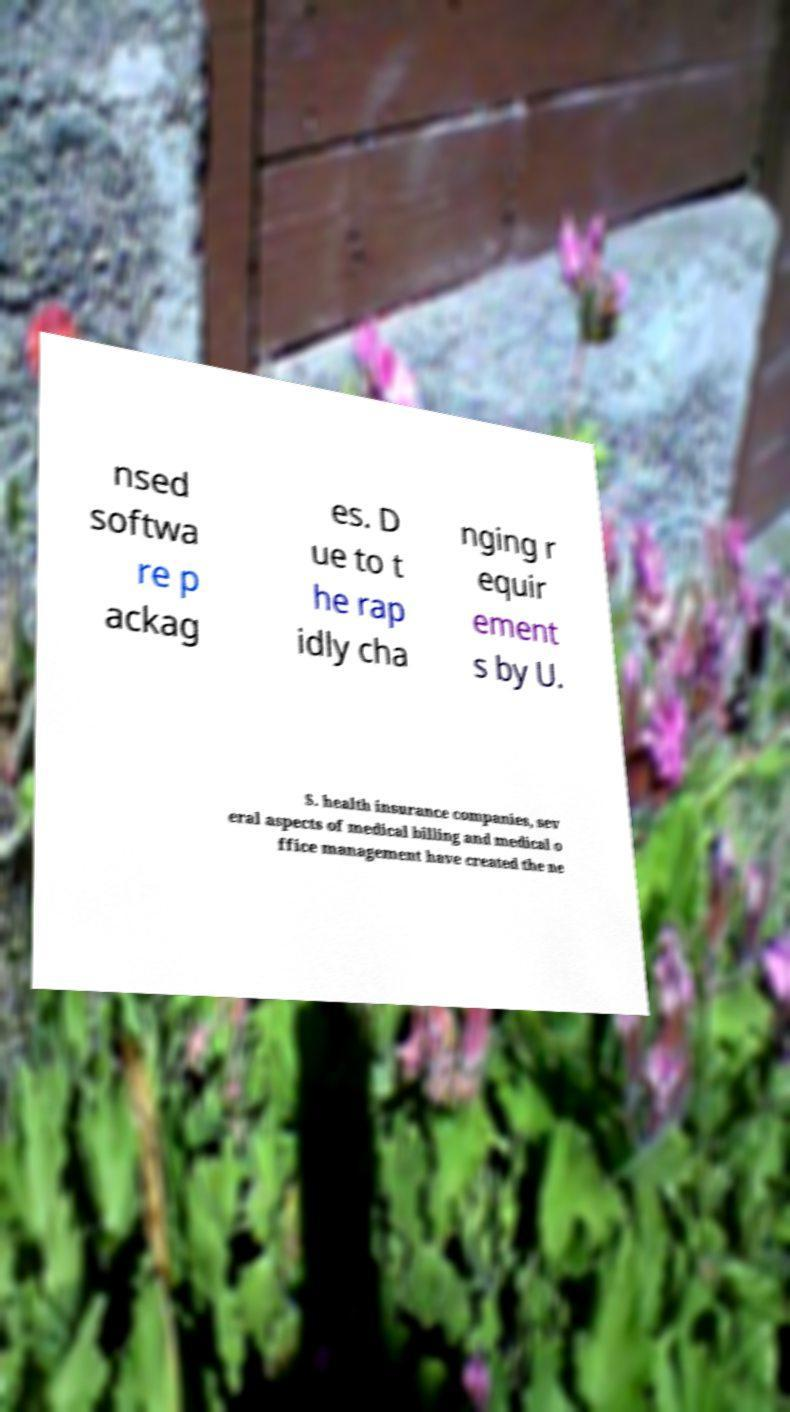Please read and relay the text visible in this image. What does it say? nsed softwa re p ackag es. D ue to t he rap idly cha nging r equir ement s by U. S. health insurance companies, sev eral aspects of medical billing and medical o ffice management have created the ne 